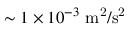<formula> <loc_0><loc_0><loc_500><loc_500>\sim 1 \times 1 0 ^ { - 3 } { m ^ { 2 } / s ^ { 2 } }</formula> 